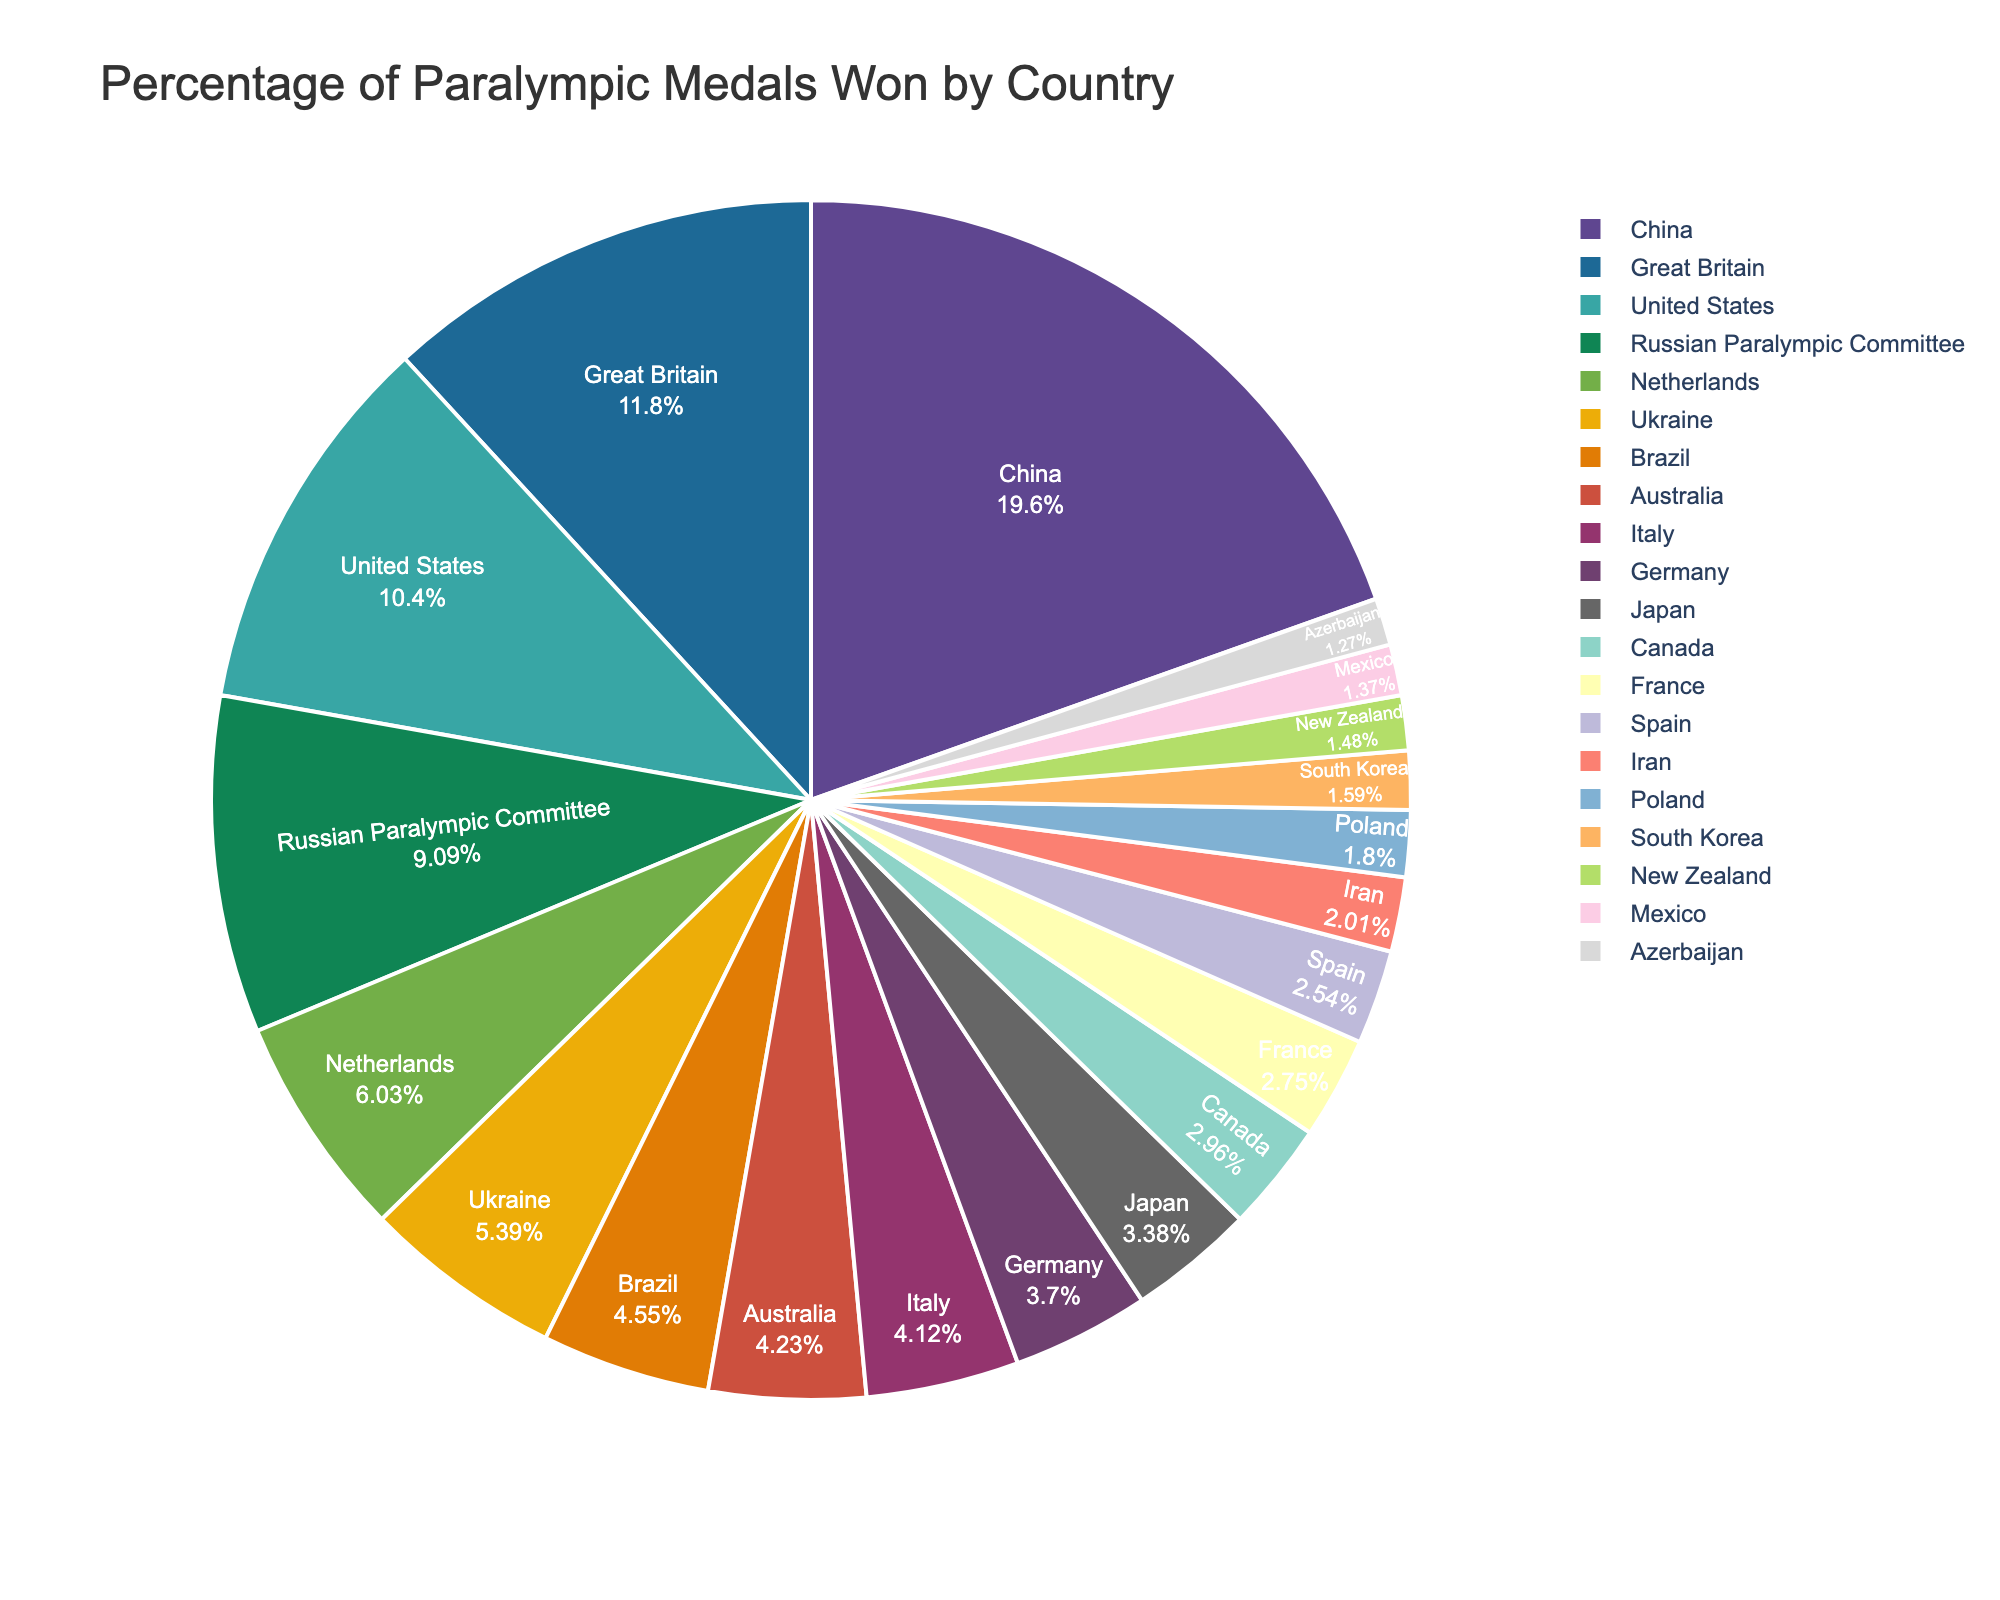Which country won the highest percentage of Paralympic medals? The pie chart shows that China occupies the largest segment. This indicates it has the highest percentage of medals won.
Answer: China Which two countries together won less than 3% of the medals? From the pie chart, New Zealand (1.4%) and Mexico (1.3%) each occupy smaller segments, which sum up to 2.7%. Both of these combined are less than 3%.
Answer: New Zealand and Mexico What is the approximate difference in the percentage of Paralympic medals won by China and the United States? China's segment indicates 18.5%, and the United States' segment indicates 9.8%. The difference is calculated by subtracting 9.8 from 18.5.
Answer: 8.7 Which countries won more medals than Brazil? The pie chart segments show China, Great Britain, the United States, the Russian Paralympic Committee, the Netherlands, and Ukraine are all larger than Brazil's segment (4.3%).
Answer: China, Great Britain, United States, Russian Paralympic Committee, Netherlands, Ukraine Which country won fewer medals, South Korea or Poland? From the chart, South Korea's segment is 1.5%, while Poland's is 1.7%. Since 1.5 is less than 1.7, South Korea won fewer medals.
Answer: South Korea Combine the percentages of medals won by the top three countries. What is the total percentage? The top three countries are China (18.5%), Great Britain (11.2%), and the United States (9.8%). Adding these together gives 18.5 + 11.2 + 9.8.
Answer: 39.5 Which countries occupy nearly identical segments on the pie chart? The segments for countries like Australia (4.0%) and Italy (3.9%) are very close in size.
Answer: Australia and Italy How does the segment size for France compare to Iran? France has a segment of 2.6%, and Iran has a segment of 1.9%. France’s segment is larger than Iran’s.
Answer: France’s segment is larger Does the combined percentage of medals won by Germany and Japan exceed that of Great Britain? Germany has 3.5%, and Japan has 3.2%, which together make 6.7%. This is less than Great Britain's 11.2%.
Answer: No Which countries won a very similar percentage of medals, around 1%? From the pie chart, South Korea (1.5%), New Zealand (1.4%), Mexico (1.3%), and Azerbaijan (1.2%) all hover around the 1% mark.
Answer: South Korea, New Zealand, Mexico, Azerbaijan 